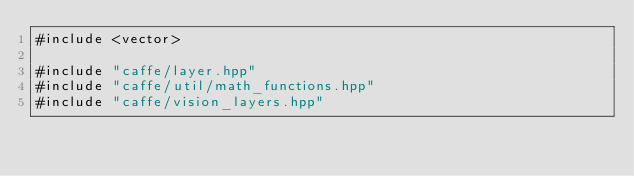<code> <loc_0><loc_0><loc_500><loc_500><_Cuda_>#include <vector>

#include "caffe/layer.hpp"
#include "caffe/util/math_functions.hpp"
#include "caffe/vision_layers.hpp"
</code> 